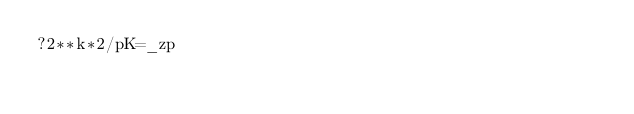Convert code to text. <code><loc_0><loc_0><loc_500><loc_500><_dc_>?2**k*2/pK=_zp</code> 